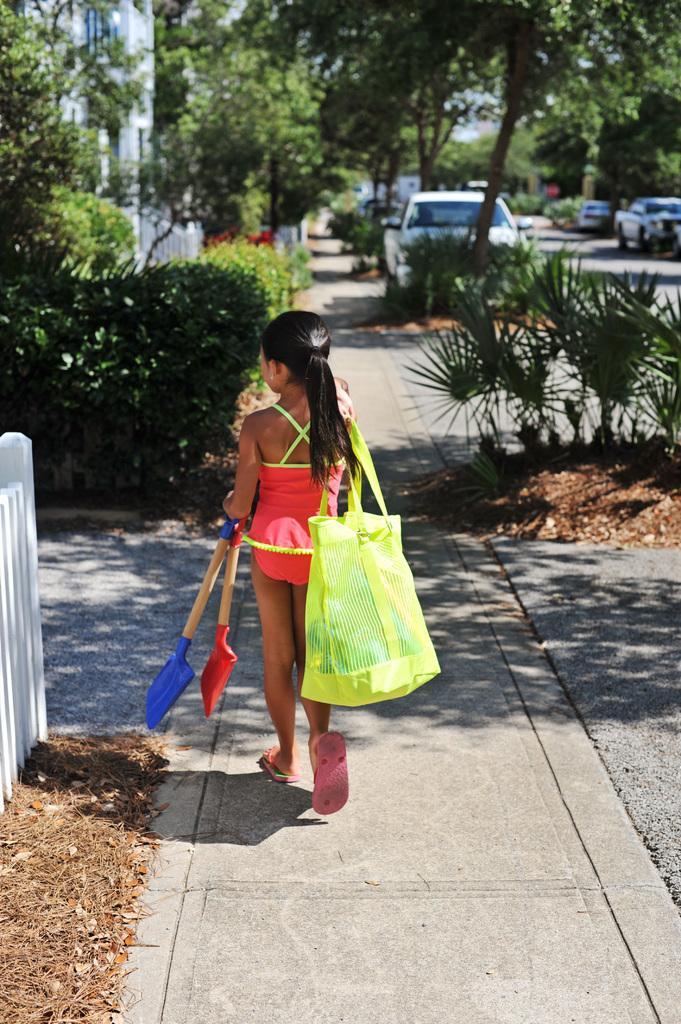Could you give a brief overview of what you see in this image? There is a small girl holding a carry bag in the foreground area of the image, there are trees, vehicles, plants and a building in the background 